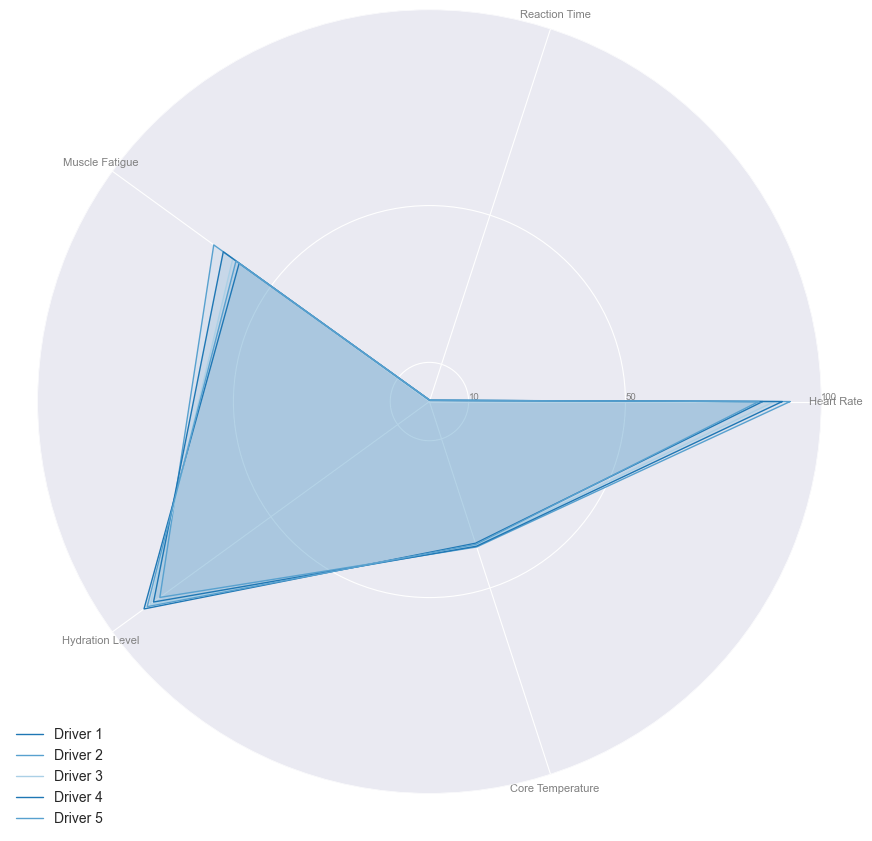What is the highest muscle fatigue value among the drivers? First, look at the Muscle Fatigue values for each driver, which are 60, 68, 62, 65, and 61. The highest value is 68.
Answer: 68 Which driver has the lowest reaction time? Check the Reaction Time values, which are 0.35, 0.32, 0.31, 0.33, and 0.34. The lowest value is 0.31, which belongs to Driver 3.
Answer: Driver 3 Is any driver's core temperature equal to 39? Look at the Core Temperature values, which are 38, 39, 38.5, 38.8, and 38.3. Only Driver 2 has a core temperature equal to 39.
Answer: Driver 2 What is the average heart rate of the drivers? Sum the Heart Rate values: 85 + 92 + 88 + 90 + 84 = 439. Divide by 5: 439/5 = 87.8.
Answer: 87.8 Which driver has the highest hydration level and lowest muscle fatigue? The highest Hydration Level is 90 (Driver 1) and the lowest Muscle Fatigue is 60 (Driver 1). So, Driver 1 has both.
Answer: Driver 1 How many drivers have a heart rate higher than 85? Check Heart Rate values: 85, 92, 88, 90, 84. Drivers 2, 3, and 4 have rates higher than 85, so 3 drivers in total.
Answer: 3 Which driver has the most balanced metrics (the most similar values across the five metrics)? Visual inspection of the radar chart can help assess which driver's values converge closer in a circular manner. Driver 1 seems the most balanced, with values close to each other regarding Heart Rate (85), Reaction Time (0.35), Muscle Fatigue (60), Hydration Level (90), and Core Temperature (38).
Answer: Driver 1 What is the difference in core temperature between the driver with the highest and the lowest core temperature? The highest Core Temperature is 39 (Driver 2) and the lowest is 38 (Driver 1). The difference is 39 - 38 = 1.
Answer: 1 How does Driver 4's muscle fatigue compare to Driver 3's? Driver 4's Muscle Fatigue is 65, while Driver 3's is 62. Hence, Driver 4's muscle fatigue is higher by 65 - 62 = 3.
Answer: 3 Which drivers have a hydration level above 88? Check Hydration Level values: 90 (Driver 1), 85 (Driver 2), 88 (Driver 3), 87 (Driver 4), and 89 (Driver 5). Drivers 1 and 5 have values above 88.
Answer: Drivers 1 and 5 